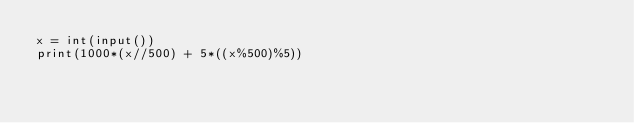<code> <loc_0><loc_0><loc_500><loc_500><_Python_>x = int(input())
print(1000*(x//500) + 5*((x%500)%5))
</code> 